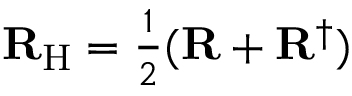<formula> <loc_0><loc_0><loc_500><loc_500>{ R } _ { H } = { \frac { 1 } { 2 } } ( { R } + { R } ^ { \dagger } )</formula> 